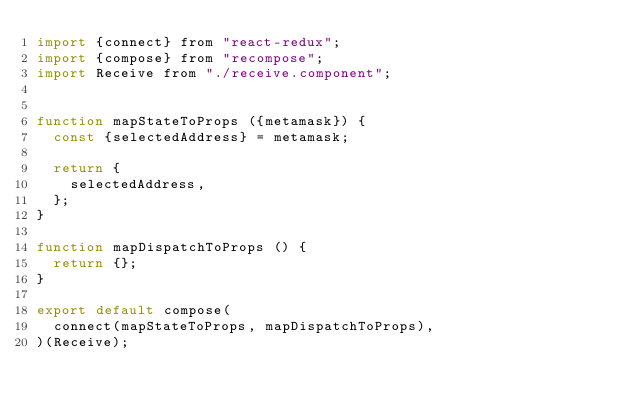<code> <loc_0><loc_0><loc_500><loc_500><_JavaScript_>import {connect} from "react-redux";
import {compose} from "recompose";
import Receive from "./receive.component";


function mapStateToProps ({metamask}) {
  const {selectedAddress} = metamask;

  return {
    selectedAddress,
  };
}

function mapDispatchToProps () {
  return {};
}

export default compose(
  connect(mapStateToProps, mapDispatchToProps),
)(Receive);
</code> 